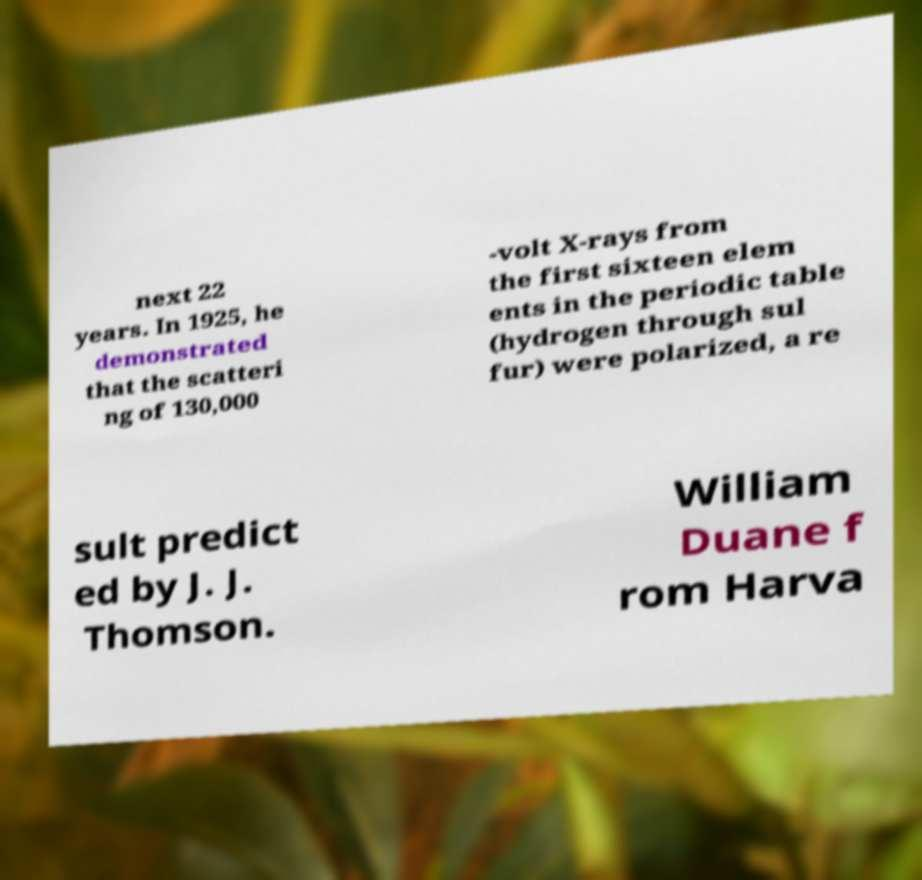Can you accurately transcribe the text from the provided image for me? next 22 years. In 1925, he demonstrated that the scatteri ng of 130,000 -volt X-rays from the first sixteen elem ents in the periodic table (hydrogen through sul fur) were polarized, a re sult predict ed by J. J. Thomson. William Duane f rom Harva 